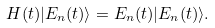<formula> <loc_0><loc_0><loc_500><loc_500>H ( t ) | E _ { n } ( t ) \rangle = E _ { n } ( t ) | E _ { n } ( t ) \rangle .</formula> 